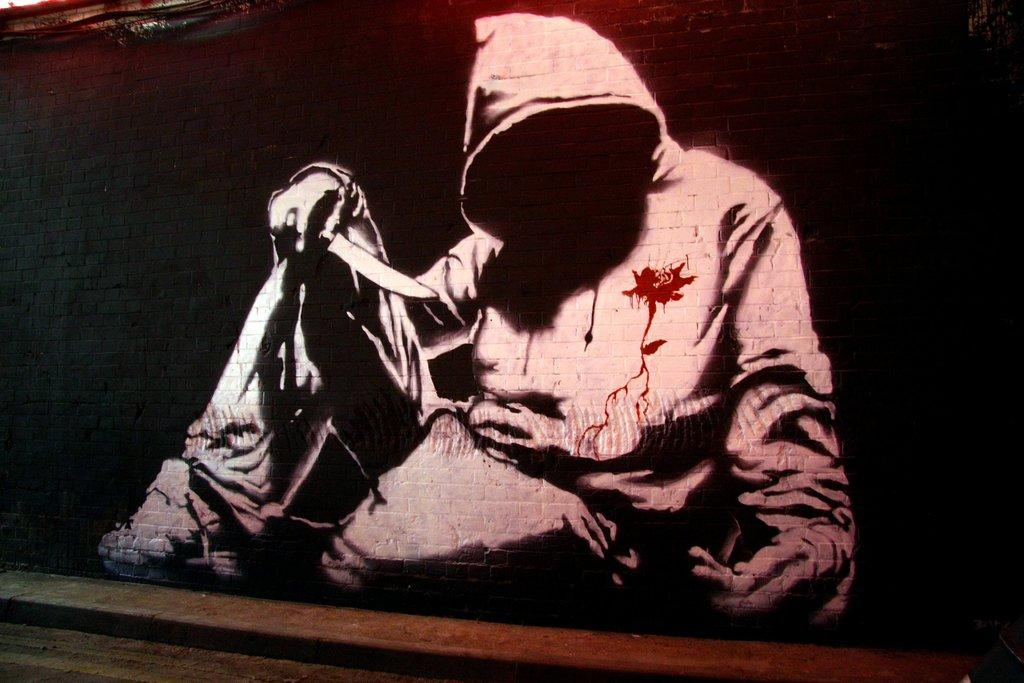What is the main subject of the image? There is a painting in the image. What is the person in the painting doing? The person in the painting is sitting. What object is the person holding in the painting? The person is holding a knife. Where is the painting located in the image? The painting is on a wall. How does the painting compare to the grandmother's memory of the event? The image does not provide any information about the grandmother's memory of the event, so it cannot be compared to the painting. 